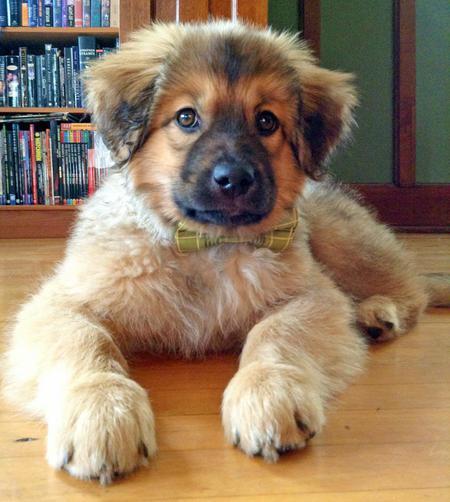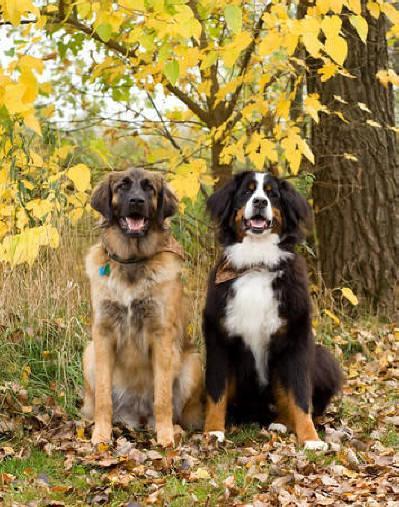The first image is the image on the left, the second image is the image on the right. Assess this claim about the two images: "Two dogs wearing something around their necks are posed side-by-side outdoors in front of yellow foliage.". Correct or not? Answer yes or no. Yes. The first image is the image on the left, the second image is the image on the right. Assess this claim about the two images: "A single dog is lying on the floor in one of the animals.". Correct or not? Answer yes or no. Yes. 